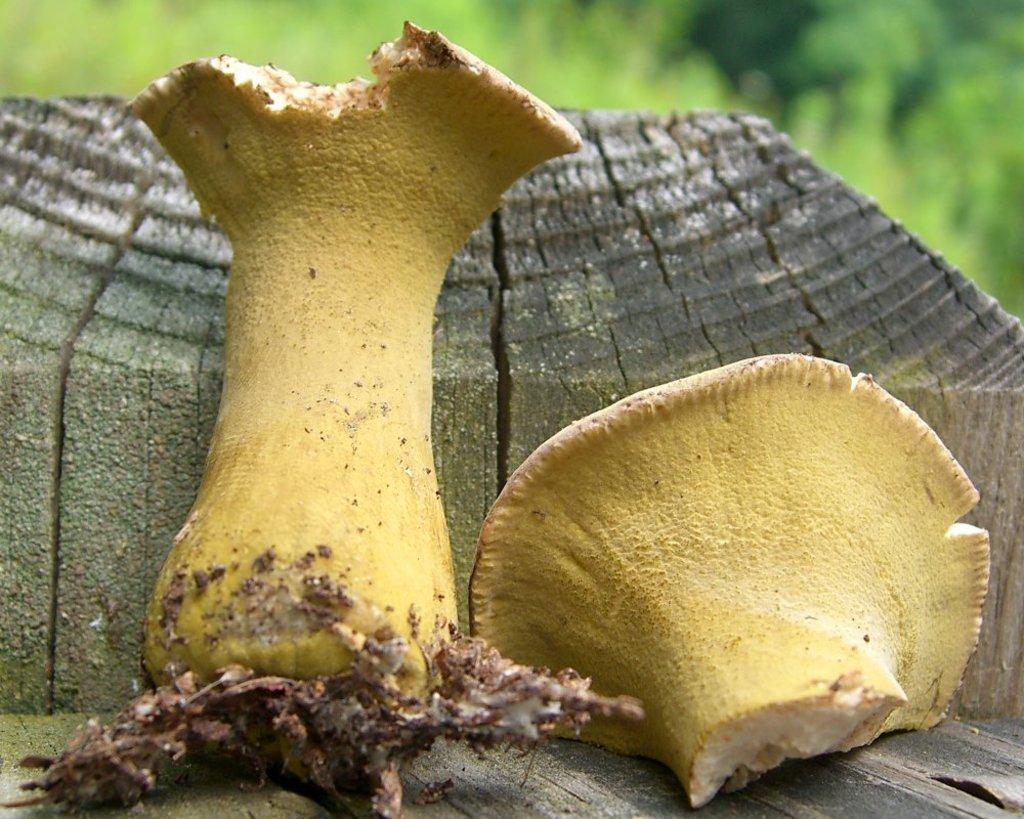How would you summarize this image in a sentence or two? There are mushroom pieces with soil on a wood. In the back it is green and blurred. 